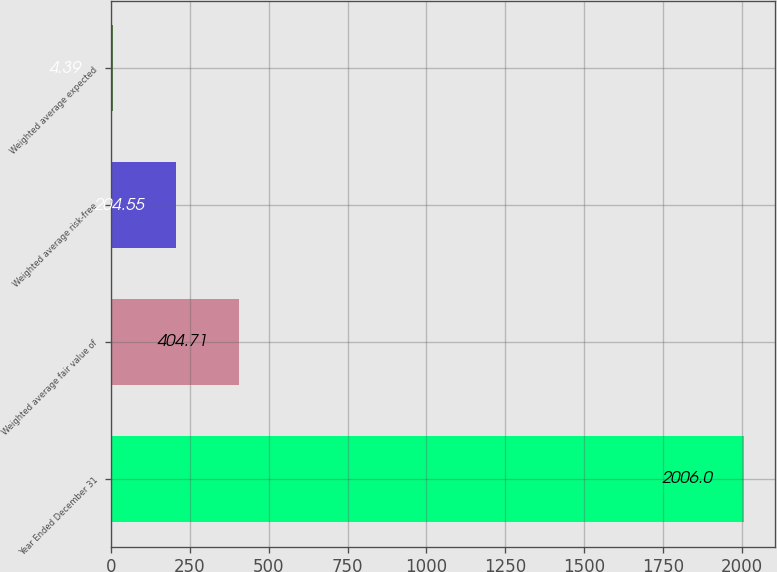<chart> <loc_0><loc_0><loc_500><loc_500><bar_chart><fcel>Year Ended December 31<fcel>Weighted average fair value of<fcel>Weighted average risk-free<fcel>Weighted average expected<nl><fcel>2006<fcel>404.71<fcel>204.55<fcel>4.39<nl></chart> 